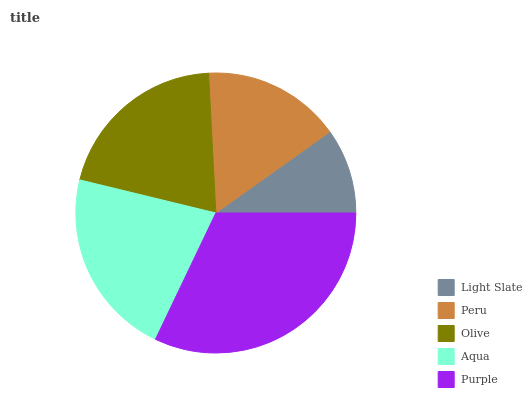Is Light Slate the minimum?
Answer yes or no. Yes. Is Purple the maximum?
Answer yes or no. Yes. Is Peru the minimum?
Answer yes or no. No. Is Peru the maximum?
Answer yes or no. No. Is Peru greater than Light Slate?
Answer yes or no. Yes. Is Light Slate less than Peru?
Answer yes or no. Yes. Is Light Slate greater than Peru?
Answer yes or no. No. Is Peru less than Light Slate?
Answer yes or no. No. Is Olive the high median?
Answer yes or no. Yes. Is Olive the low median?
Answer yes or no. Yes. Is Peru the high median?
Answer yes or no. No. Is Purple the low median?
Answer yes or no. No. 